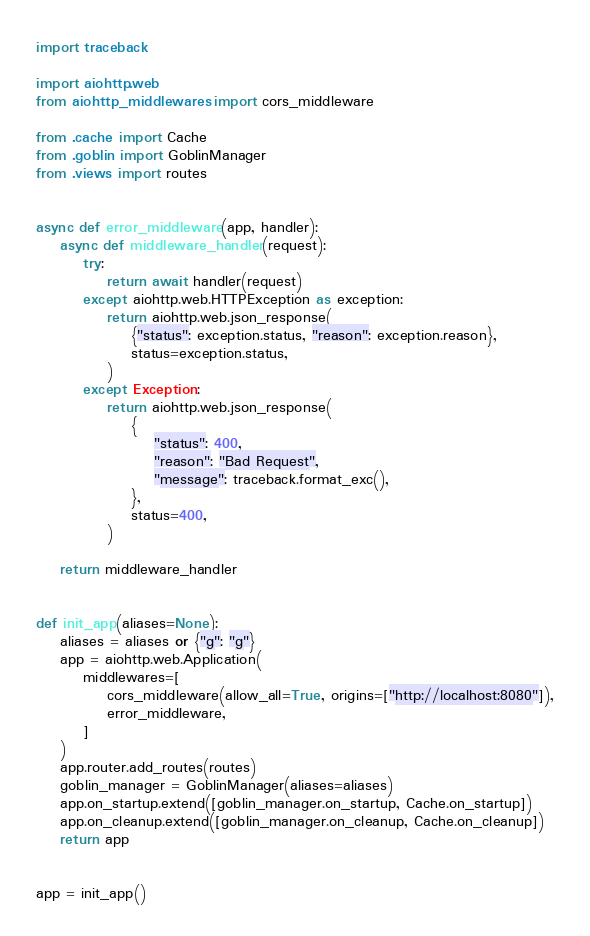<code> <loc_0><loc_0><loc_500><loc_500><_Python_>import traceback

import aiohttp.web
from aiohttp_middlewares import cors_middleware

from .cache import Cache
from .goblin import GoblinManager
from .views import routes


async def error_middleware(app, handler):
    async def middleware_handler(request):
        try:
            return await handler(request)
        except aiohttp.web.HTTPException as exception:
            return aiohttp.web.json_response(
                {"status": exception.status, "reason": exception.reason},
                status=exception.status,
            )
        except Exception:
            return aiohttp.web.json_response(
                {
                    "status": 400,
                    "reason": "Bad Request",
                    "message": traceback.format_exc(),
                },
                status=400,
            )

    return middleware_handler


def init_app(aliases=None):
    aliases = aliases or {"g": "g"}
    app = aiohttp.web.Application(
        middlewares=[
            cors_middleware(allow_all=True, origins=["http://localhost:8080"]),
            error_middleware,
        ]
    )
    app.router.add_routes(routes)
    goblin_manager = GoblinManager(aliases=aliases)
    app.on_startup.extend([goblin_manager.on_startup, Cache.on_startup])
    app.on_cleanup.extend([goblin_manager.on_cleanup, Cache.on_cleanup])
    return app


app = init_app()
</code> 